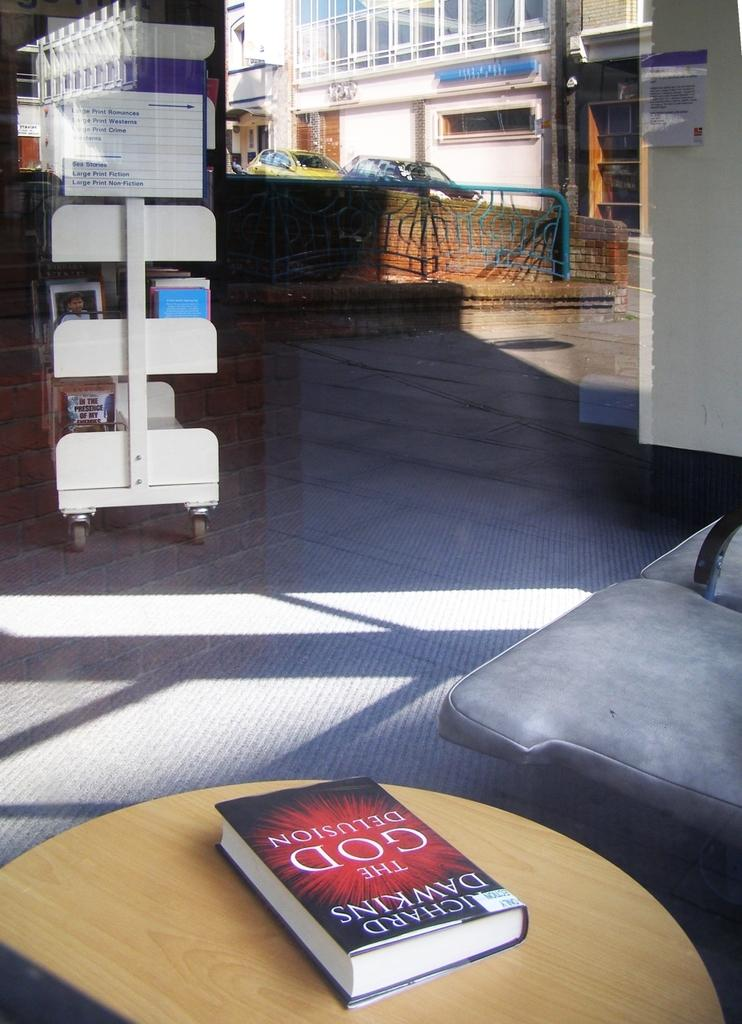What object is placed on the table in the image? There is a book on the table in the image. What piece of furniture is located next to the table? There is a chair next to the table in the image. What type of storage is present for books in the image? There is a books rack in the image. What type of vehicles can be seen in the image? Cars are visible in the image. What type of structure is present in the image? There is a building in the image. Can you tell me how many times the person in the image sneezes? There is no person present in the image, and therefore no sneezing can be observed. Is there a shirt hanging on the building in the image? There is no shirt visible on the building in the image. 